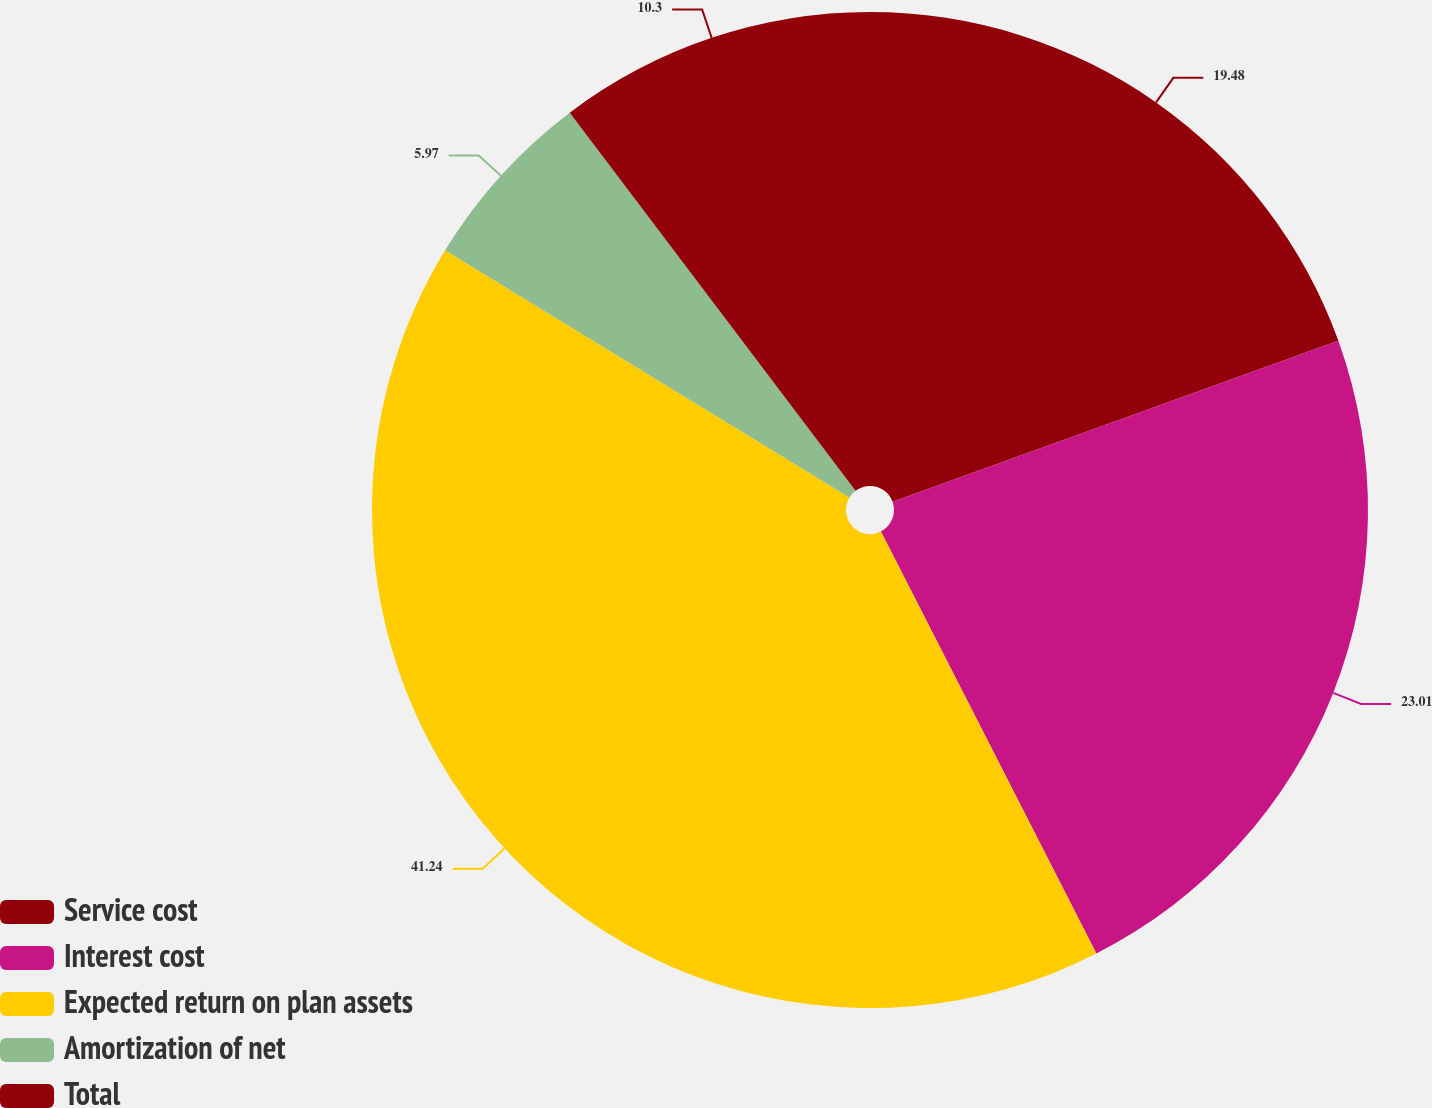Convert chart to OTSL. <chart><loc_0><loc_0><loc_500><loc_500><pie_chart><fcel>Service cost<fcel>Interest cost<fcel>Expected return on plan assets<fcel>Amortization of net<fcel>Total<nl><fcel>19.48%<fcel>23.01%<fcel>41.24%<fcel>5.97%<fcel>10.3%<nl></chart> 